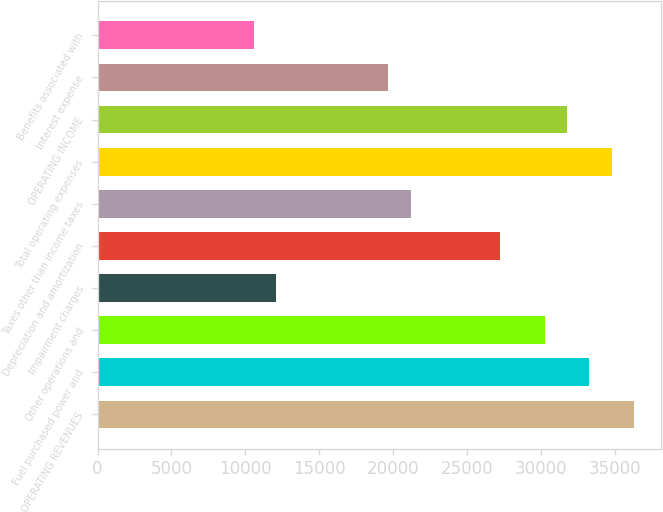Convert chart. <chart><loc_0><loc_0><loc_500><loc_500><bar_chart><fcel>OPERATING REVENUES<fcel>Fuel purchased power and<fcel>Other operations and<fcel>Impairment charges<fcel>Depreciation and amortization<fcel>Taxes other than income taxes<fcel>Total operating expenses<fcel>OPERATING INCOME<fcel>Interest expense<fcel>Benefits associated with<nl><fcel>36320.9<fcel>33294.5<fcel>30268.1<fcel>12109.6<fcel>27241.6<fcel>21188.8<fcel>34807.7<fcel>31781.3<fcel>19675.6<fcel>10596.4<nl></chart> 